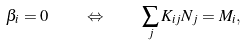Convert formula to latex. <formula><loc_0><loc_0><loc_500><loc_500>\beta _ { i } = 0 \quad \Leftrightarrow \quad \sum _ { j } K _ { i j } N _ { j } = M _ { i } ,</formula> 